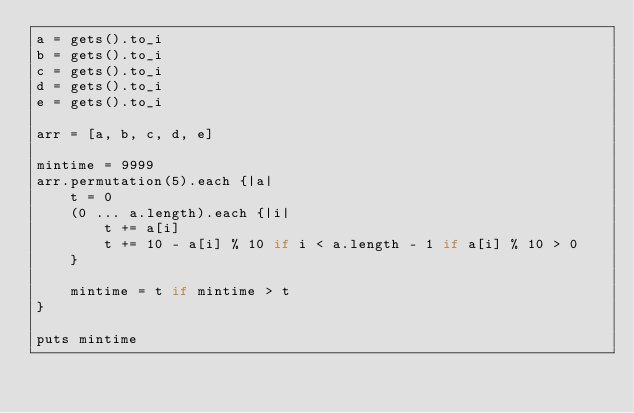<code> <loc_0><loc_0><loc_500><loc_500><_Ruby_>a = gets().to_i
b = gets().to_i
c = gets().to_i
d = gets().to_i
e = gets().to_i

arr = [a, b, c, d, e]

mintime = 9999
arr.permutation(5).each {|a|
	t = 0
	(0 ... a.length).each {|i|
		t += a[i]
		t += 10 - a[i] % 10 if i < a.length - 1 if a[i] % 10 > 0
	}

	mintime = t if mintime > t
}

puts mintime
</code> 